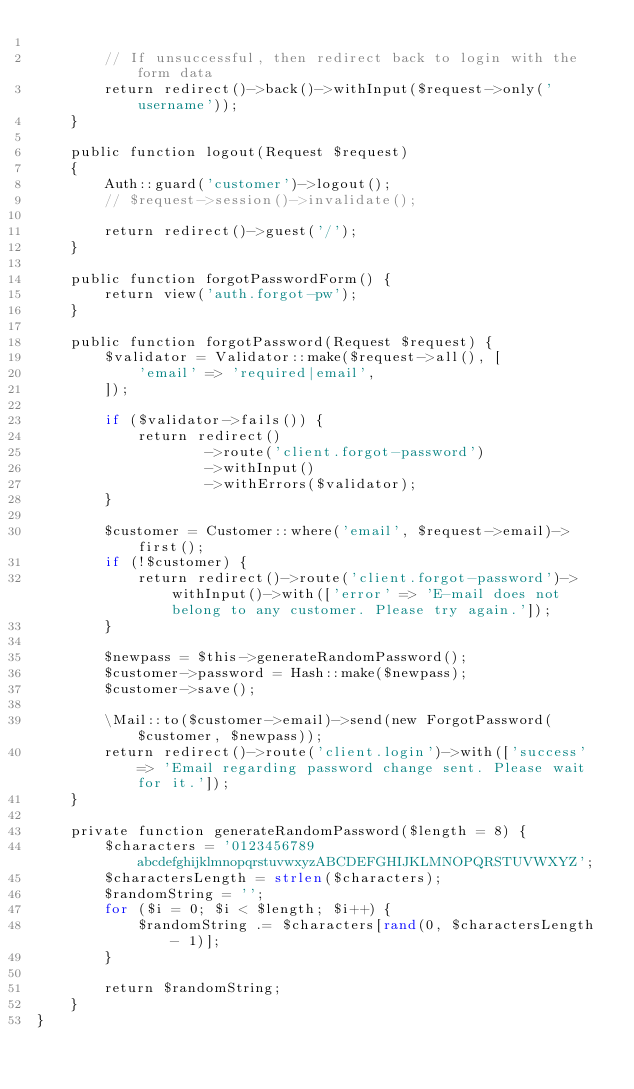<code> <loc_0><loc_0><loc_500><loc_500><_PHP_>
        // If unsuccessful, then redirect back to login with the form data
        return redirect()->back()->withInput($request->only('username'));
    }

    public function logout(Request $request)
    {
        Auth::guard('customer')->logout();
        // $request->session()->invalidate();

        return redirect()->guest('/');
    }

    public function forgotPasswordForm() {
        return view('auth.forgot-pw');
    }

    public function forgotPassword(Request $request) {
        $validator = Validator::make($request->all(), [
            'email' => 'required|email',
        ]);

        if ($validator->fails()) {
            return redirect()
                    ->route('client.forgot-password')
                    ->withInput()
                    ->withErrors($validator);
        }

        $customer = Customer::where('email', $request->email)->first();
        if (!$customer) {
            return redirect()->route('client.forgot-password')->withInput()->with(['error' => 'E-mail does not belong to any customer. Please try again.']);
        }

        $newpass = $this->generateRandomPassword();
        $customer->password = Hash::make($newpass);
        $customer->save();

        \Mail::to($customer->email)->send(new ForgotPassword($customer, $newpass));
        return redirect()->route('client.login')->with(['success' => 'Email regarding password change sent. Please wait for it.']);
    }

    private function generateRandomPassword($length = 8) {
        $characters = '0123456789abcdefghijklmnopqrstuvwxyzABCDEFGHIJKLMNOPQRSTUVWXYZ';
        $charactersLength = strlen($characters);
        $randomString = '';
        for ($i = 0; $i < $length; $i++) {
            $randomString .= $characters[rand(0, $charactersLength - 1)];
        }

        return $randomString;
    }
}
</code> 